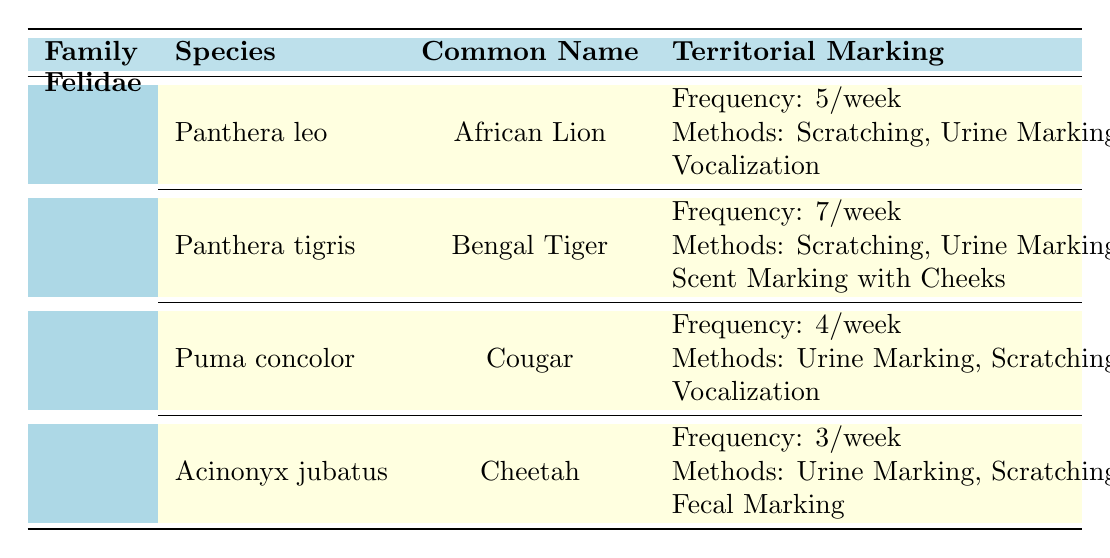What is the frequency of territorial marking behaviors for the Bengal Tiger? The table specifies the frequency of territorial marking behaviors for each species. For the Bengal Tiger (Panthera tigris), the frequency is explicitly mentioned as 7 per week.
Answer: 7 per week Which wild cat species displays the highest frequency of territorial marking behaviors? By comparing the frequency values provided in the table, the Bengal Tiger (Panthera tigris) has the highest frequency at 7 per week compared to the other species.
Answer: Bengal Tiger How many different marking methods are used by the African Lion? Checking the methods listed for the African Lion (Panthera leo), there are three methods: Scratching, Urine Marking, and Vocalization. Therefore, the total number of marking methods is three.
Answer: 3 What is the total frequency of territorial marking behaviors for the Cougar and the Cheetah combined? The Cougar has a frequency of 4 per week and the Cheetah has a frequency of 3 per week. Adding these together gives: 4 + 3 = 7 per week.
Answer: 7 per week Is it true that all wild cat species observed utilize urine marking as a method of territorial marking? Reviewing the methods used by each species: African Lion, Bengal Tiger, Cougar, and Cheetah; all species list Urine Marking as one of their methods. Therefore, the statement is true.
Answer: Yes Which wild cat species uses fecal marking as a method of territorial marking? According to the table, only the Cheetah (Acinonyx jubatus) uses Fecal Marking as one of its methods. Other species do not list this method.
Answer: Cheetah What is the average frequency of territorial marking behaviors across all species? To find the average, sum the frequencies of all species: (5 + 7 + 4 + 3) = 19, and divide by the number of species (4). So, 19/4 = 4.75.
Answer: 4.75 per week How many of the species utilize vocalization as a marking method? The African Lion and the Cougar both list Vocalization as marking methods. Therefore, two of the species utilize Vocalization.
Answer: 2 Which wild cat species has the least frequency of territorial marking behaviors and what is that frequency? The Cheetah (Acinonyx jubatus) has the lowest frequency of 3 per week, as indicated in the table.
Answer: Cheetah, 3 per week 